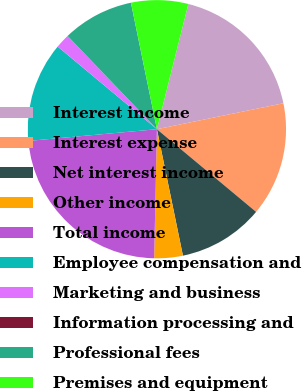<chart> <loc_0><loc_0><loc_500><loc_500><pie_chart><fcel>Interest income<fcel>Interest expense<fcel>Net interest income<fcel>Other income<fcel>Total income<fcel>Employee compensation and<fcel>Marketing and business<fcel>Information processing and<fcel>Professional fees<fcel>Premises and equipment<nl><fcel>17.86%<fcel>14.28%<fcel>10.71%<fcel>3.57%<fcel>23.21%<fcel>12.5%<fcel>1.79%<fcel>0.0%<fcel>8.93%<fcel>7.14%<nl></chart> 